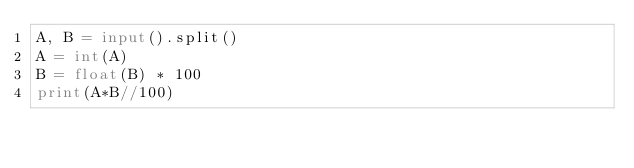<code> <loc_0><loc_0><loc_500><loc_500><_Python_>A, B = input().split()
A = int(A)
B = float(B) * 100
print(A*B//100)</code> 